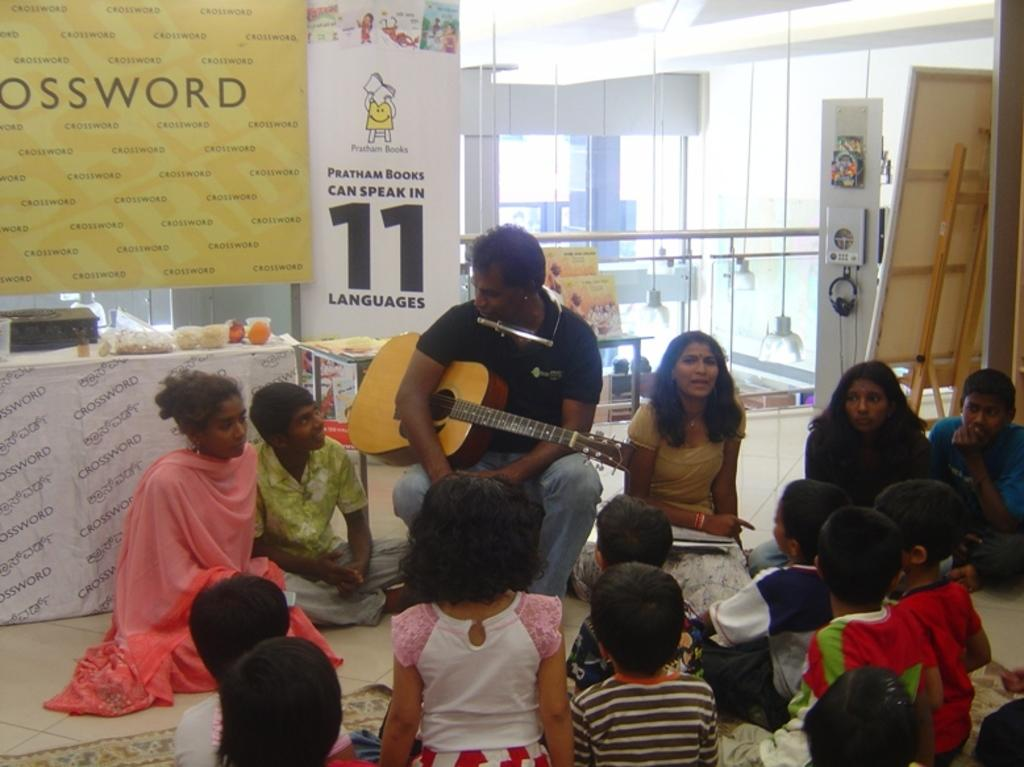What are the people in the image doing? There is a group of people sitting in the image. Can you describe any specific activity they are engaged in? One person is holding a guitar. What can be seen in the background of the image? There is a glass and many boards attached in the background of the image. How many cherries are on the bomb in the image? There is no bomb or cherries present in the image. What type of drawer is visible in the image? There is no drawer present in the image. 